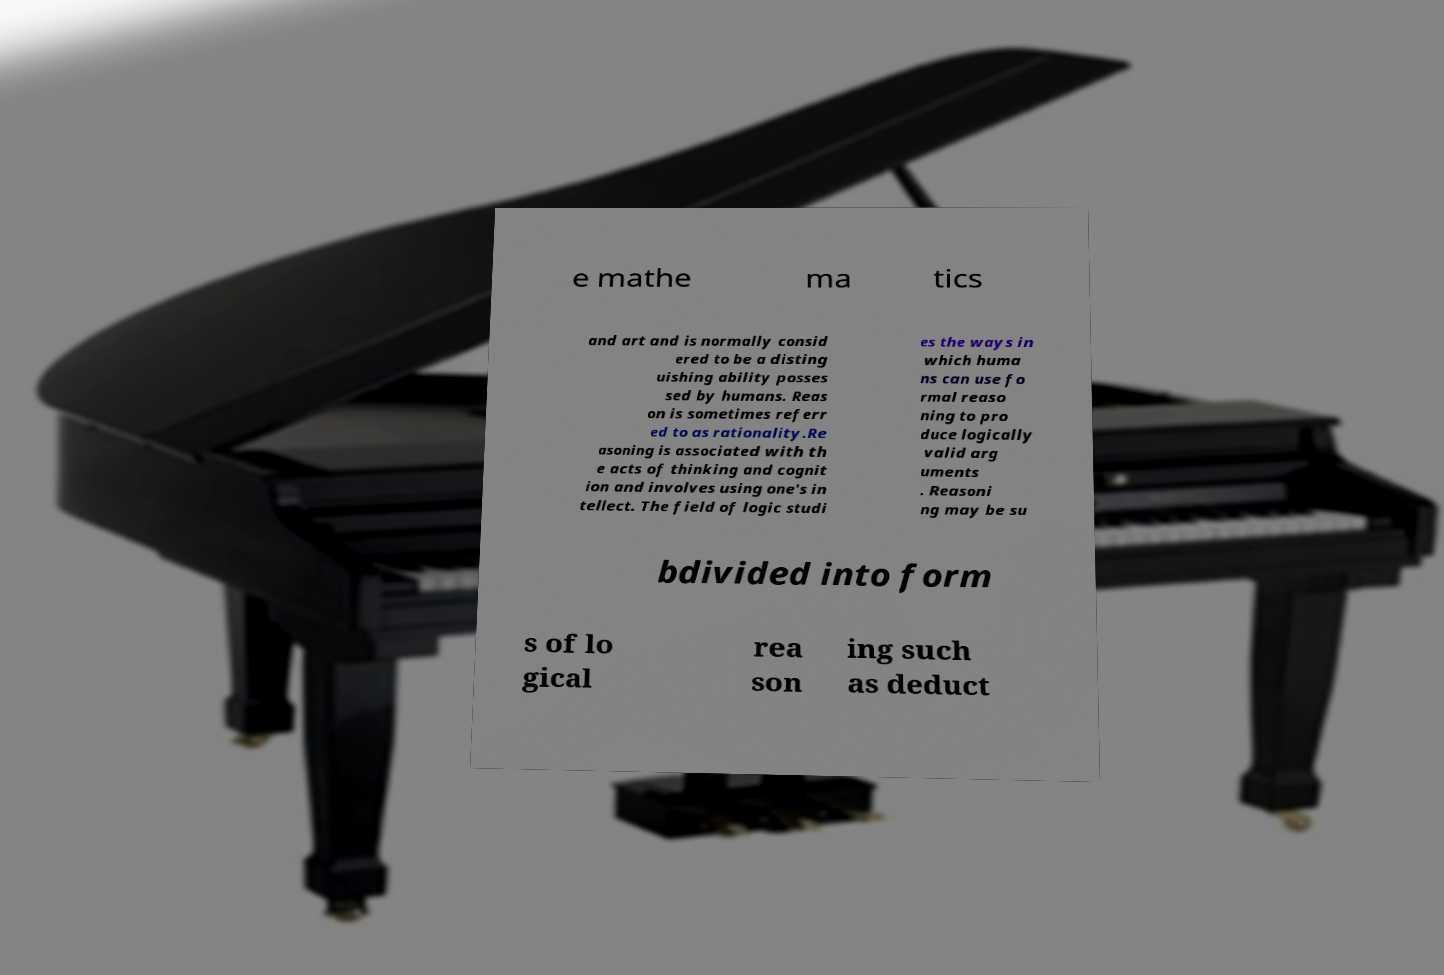For documentation purposes, I need the text within this image transcribed. Could you provide that? e mathe ma tics and art and is normally consid ered to be a disting uishing ability posses sed by humans. Reas on is sometimes referr ed to as rationality.Re asoning is associated with th e acts of thinking and cognit ion and involves using one's in tellect. The field of logic studi es the ways in which huma ns can use fo rmal reaso ning to pro duce logically valid arg uments . Reasoni ng may be su bdivided into form s of lo gical rea son ing such as deduct 